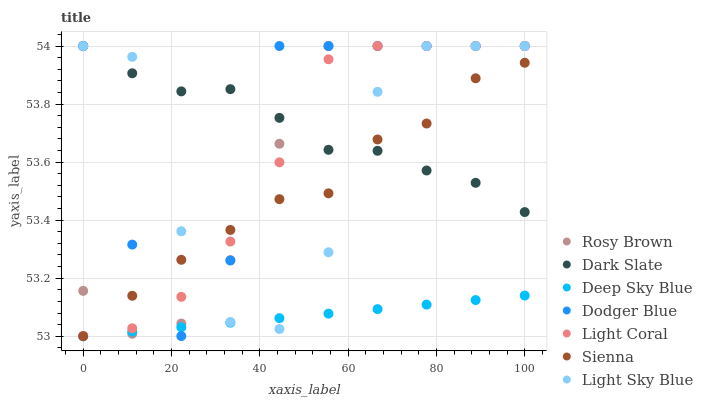Does Deep Sky Blue have the minimum area under the curve?
Answer yes or no. Yes. Does Dodger Blue have the maximum area under the curve?
Answer yes or no. Yes. Does Rosy Brown have the minimum area under the curve?
Answer yes or no. No. Does Rosy Brown have the maximum area under the curve?
Answer yes or no. No. Is Deep Sky Blue the smoothest?
Answer yes or no. Yes. Is Light Sky Blue the roughest?
Answer yes or no. Yes. Is Rosy Brown the smoothest?
Answer yes or no. No. Is Rosy Brown the roughest?
Answer yes or no. No. Does Sienna have the lowest value?
Answer yes or no. Yes. Does Rosy Brown have the lowest value?
Answer yes or no. No. Does Dodger Blue have the highest value?
Answer yes or no. Yes. Does Deep Sky Blue have the highest value?
Answer yes or no. No. Is Deep Sky Blue less than Light Coral?
Answer yes or no. Yes. Is Light Coral greater than Deep Sky Blue?
Answer yes or no. Yes. Does Rosy Brown intersect Dark Slate?
Answer yes or no. Yes. Is Rosy Brown less than Dark Slate?
Answer yes or no. No. Is Rosy Brown greater than Dark Slate?
Answer yes or no. No. Does Deep Sky Blue intersect Light Coral?
Answer yes or no. No. 